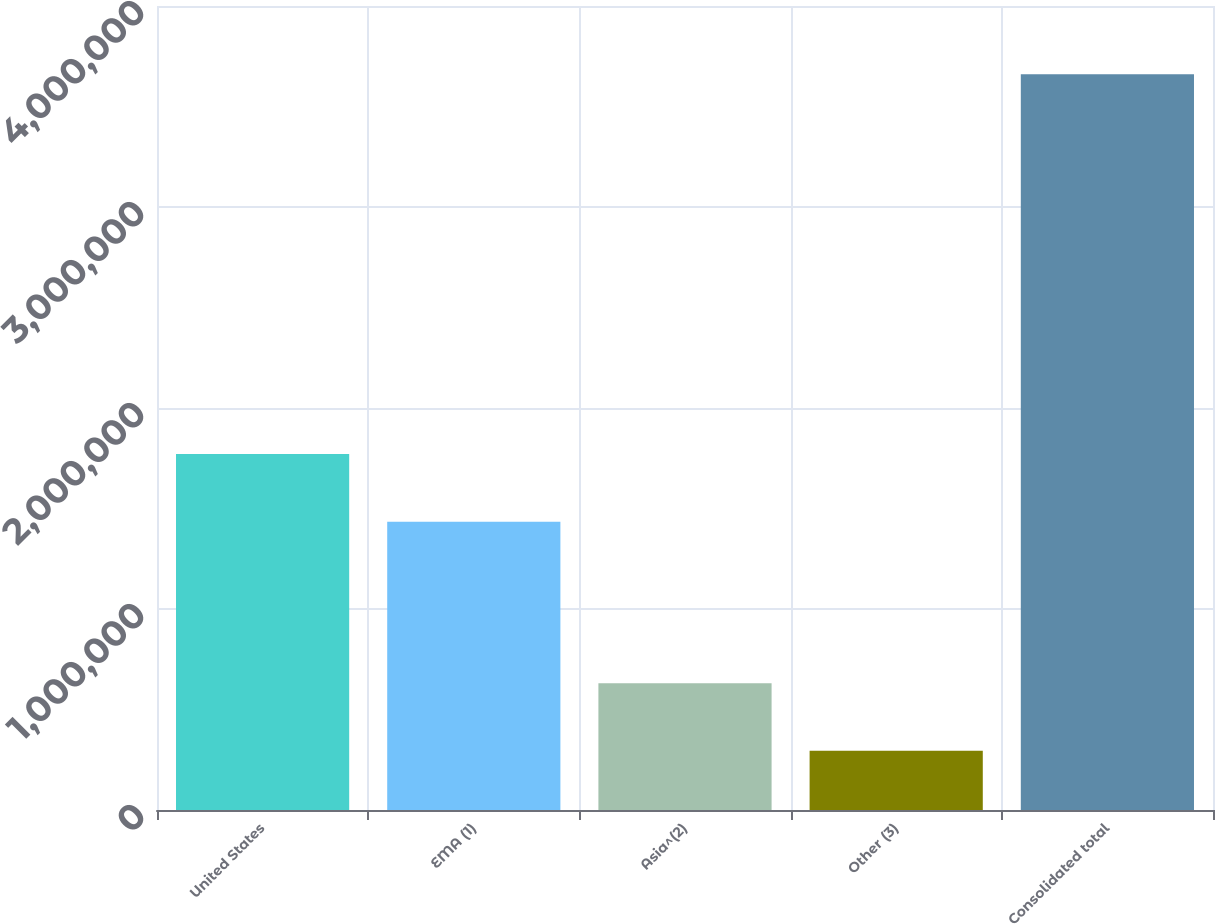Convert chart to OTSL. <chart><loc_0><loc_0><loc_500><loc_500><bar_chart><fcel>United States<fcel>EMA (1)<fcel>Asia^(2)<fcel>Other (3)<fcel>Consolidated total<nl><fcel>1.77115e+06<fcel>1.43451e+06<fcel>631018<fcel>294372<fcel>3.66083e+06<nl></chart> 